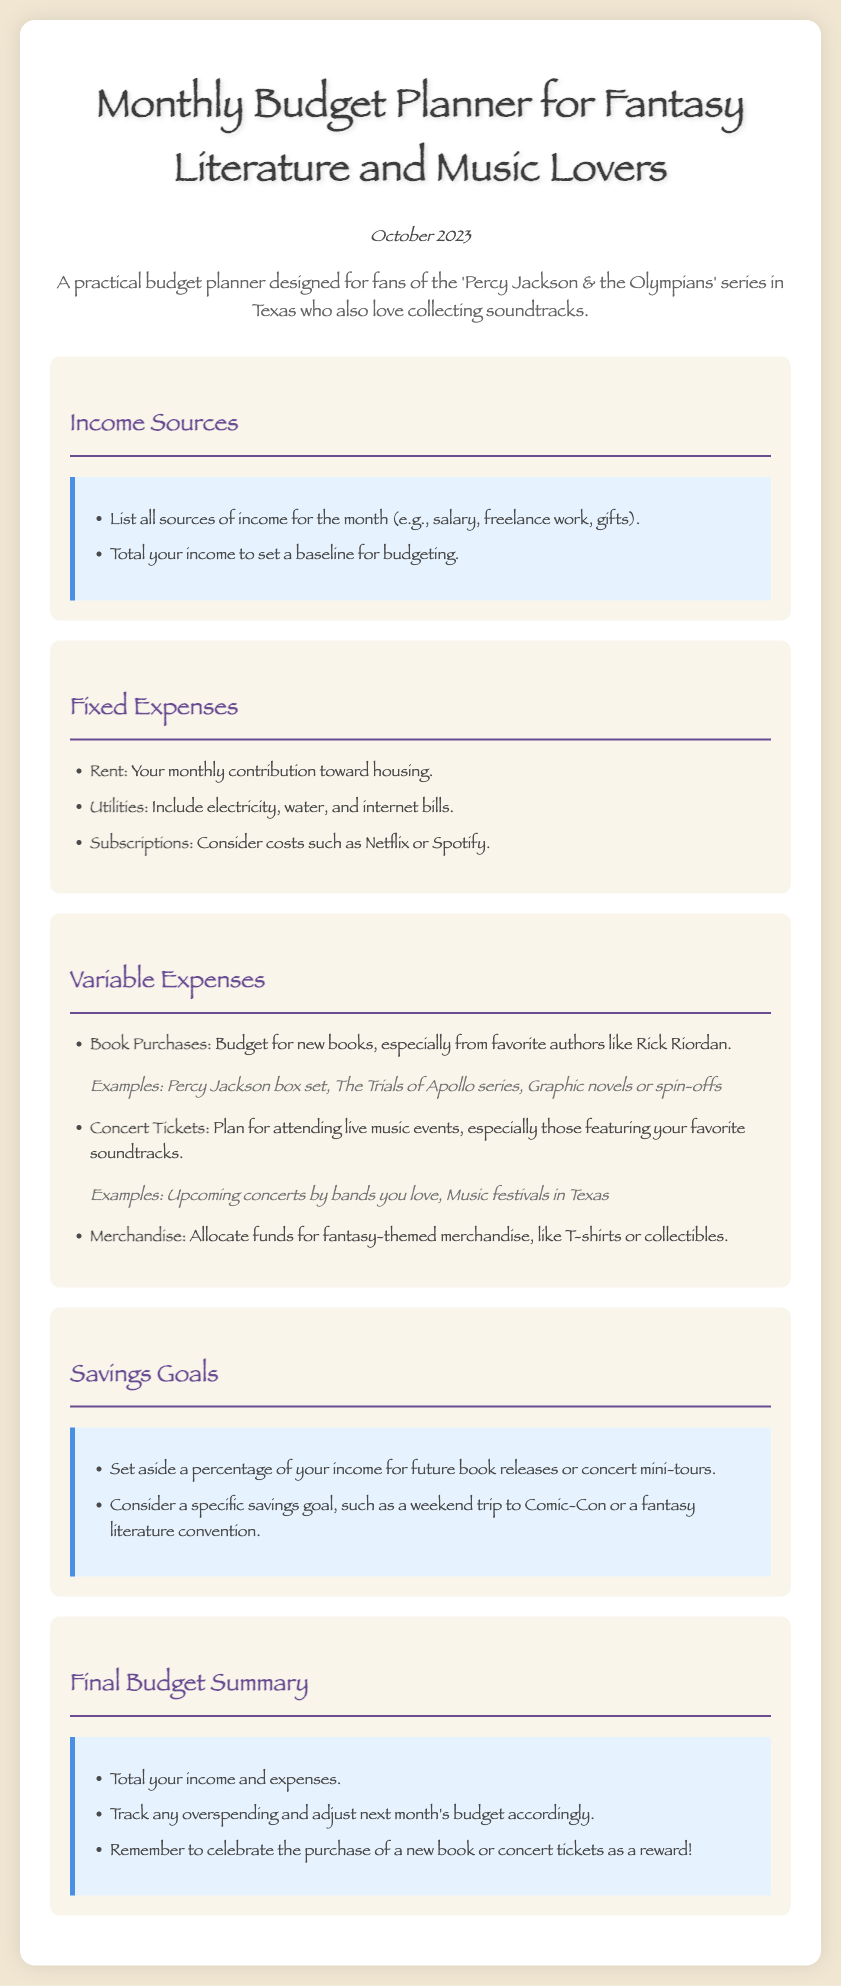What is the title of the document? The title is stated prominently at the top of the document.
Answer: Monthly Budget Planner for Fantasy Literature and Music Lovers What month is the budget planner for? The document clearly states the relevant month.
Answer: October 2023 What type of expenses includes rent? The section on Fixed Expenses encompasses housing-related costs.
Answer: Fixed Expenses Name one type of merchandise planned in the budget. The document lists merchandise as part of the variable expenses specifically for fantasy fans.
Answer: Fantasy-themed merchandise What is one example of a book purchase listed? The document provides specific examples of possible book purchases to include in the budget.
Answer: Percy Jackson box set What should be tracked in the Final Budget Summary? The summary section emphasizes the need to monitor specific financial metrics for better budgeting.
Answer: Overspending What is a suggested savings goal mentioned? The document encourages setting a particular financial aim related to future events or purchases.
Answer: Weekend trip to Comic-Con What type of events should concert tickets be planned for? The variable expenses section indicates the types of events for which to budget concert tickets.
Answer: Live music events What font style is used throughout the document? The choice of font style is noted in the body styling of the document.
Answer: Papyrus 